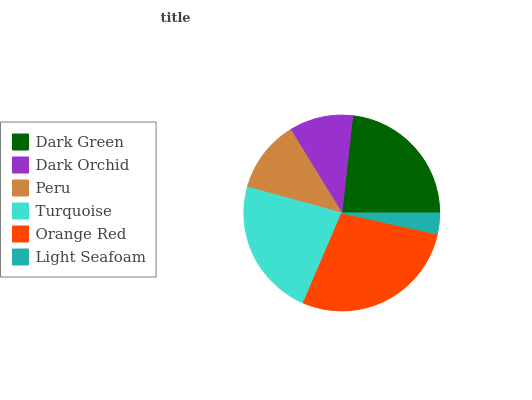Is Light Seafoam the minimum?
Answer yes or no. Yes. Is Orange Red the maximum?
Answer yes or no. Yes. Is Dark Orchid the minimum?
Answer yes or no. No. Is Dark Orchid the maximum?
Answer yes or no. No. Is Dark Green greater than Dark Orchid?
Answer yes or no. Yes. Is Dark Orchid less than Dark Green?
Answer yes or no. Yes. Is Dark Orchid greater than Dark Green?
Answer yes or no. No. Is Dark Green less than Dark Orchid?
Answer yes or no. No. Is Turquoise the high median?
Answer yes or no. Yes. Is Peru the low median?
Answer yes or no. Yes. Is Orange Red the high median?
Answer yes or no. No. Is Light Seafoam the low median?
Answer yes or no. No. 